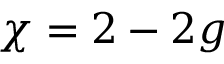<formula> <loc_0><loc_0><loc_500><loc_500>\chi = 2 - 2 g</formula> 